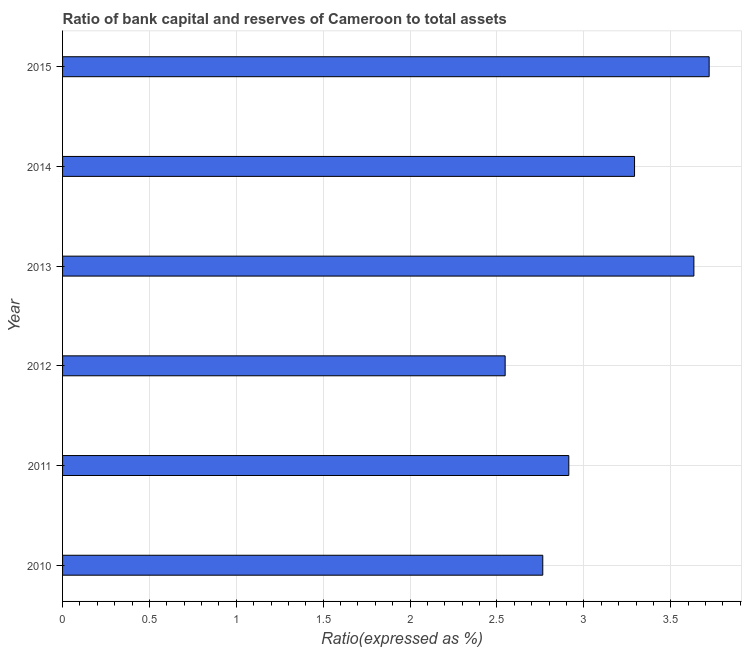Does the graph contain grids?
Give a very brief answer. Yes. What is the title of the graph?
Give a very brief answer. Ratio of bank capital and reserves of Cameroon to total assets. What is the label or title of the X-axis?
Your response must be concise. Ratio(expressed as %). What is the bank capital to assets ratio in 2014?
Offer a very short reply. 3.29. Across all years, what is the maximum bank capital to assets ratio?
Offer a very short reply. 3.72. Across all years, what is the minimum bank capital to assets ratio?
Make the answer very short. 2.55. In which year was the bank capital to assets ratio maximum?
Your response must be concise. 2015. In which year was the bank capital to assets ratio minimum?
Your answer should be very brief. 2012. What is the sum of the bank capital to assets ratio?
Keep it short and to the point. 18.87. What is the difference between the bank capital to assets ratio in 2011 and 2012?
Your answer should be very brief. 0.37. What is the average bank capital to assets ratio per year?
Provide a short and direct response. 3.15. What is the median bank capital to assets ratio?
Give a very brief answer. 3.1. In how many years, is the bank capital to assets ratio greater than 1 %?
Provide a short and direct response. 6. Do a majority of the years between 2015 and 2011 (inclusive) have bank capital to assets ratio greater than 0.5 %?
Ensure brevity in your answer.  Yes. What is the ratio of the bank capital to assets ratio in 2010 to that in 2012?
Offer a terse response. 1.08. What is the difference between the highest and the second highest bank capital to assets ratio?
Keep it short and to the point. 0.09. What is the difference between the highest and the lowest bank capital to assets ratio?
Offer a very short reply. 1.17. How many years are there in the graph?
Make the answer very short. 6. Are the values on the major ticks of X-axis written in scientific E-notation?
Provide a succinct answer. No. What is the Ratio(expressed as %) in 2010?
Offer a very short reply. 2.76. What is the Ratio(expressed as %) of 2011?
Provide a short and direct response. 2.91. What is the Ratio(expressed as %) in 2012?
Make the answer very short. 2.55. What is the Ratio(expressed as %) of 2013?
Make the answer very short. 3.63. What is the Ratio(expressed as %) in 2014?
Keep it short and to the point. 3.29. What is the Ratio(expressed as %) in 2015?
Offer a terse response. 3.72. What is the difference between the Ratio(expressed as %) in 2010 and 2011?
Give a very brief answer. -0.15. What is the difference between the Ratio(expressed as %) in 2010 and 2012?
Offer a very short reply. 0.22. What is the difference between the Ratio(expressed as %) in 2010 and 2013?
Give a very brief answer. -0.87. What is the difference between the Ratio(expressed as %) in 2010 and 2014?
Keep it short and to the point. -0.53. What is the difference between the Ratio(expressed as %) in 2010 and 2015?
Offer a terse response. -0.96. What is the difference between the Ratio(expressed as %) in 2011 and 2012?
Offer a very short reply. 0.37. What is the difference between the Ratio(expressed as %) in 2011 and 2013?
Ensure brevity in your answer.  -0.72. What is the difference between the Ratio(expressed as %) in 2011 and 2014?
Give a very brief answer. -0.38. What is the difference between the Ratio(expressed as %) in 2011 and 2015?
Give a very brief answer. -0.81. What is the difference between the Ratio(expressed as %) in 2012 and 2013?
Your response must be concise. -1.09. What is the difference between the Ratio(expressed as %) in 2012 and 2014?
Ensure brevity in your answer.  -0.74. What is the difference between the Ratio(expressed as %) in 2012 and 2015?
Provide a succinct answer. -1.17. What is the difference between the Ratio(expressed as %) in 2013 and 2014?
Offer a terse response. 0.34. What is the difference between the Ratio(expressed as %) in 2013 and 2015?
Keep it short and to the point. -0.09. What is the difference between the Ratio(expressed as %) in 2014 and 2015?
Give a very brief answer. -0.43. What is the ratio of the Ratio(expressed as %) in 2010 to that in 2011?
Your answer should be very brief. 0.95. What is the ratio of the Ratio(expressed as %) in 2010 to that in 2012?
Your answer should be compact. 1.08. What is the ratio of the Ratio(expressed as %) in 2010 to that in 2013?
Your response must be concise. 0.76. What is the ratio of the Ratio(expressed as %) in 2010 to that in 2014?
Your answer should be compact. 0.84. What is the ratio of the Ratio(expressed as %) in 2010 to that in 2015?
Give a very brief answer. 0.74. What is the ratio of the Ratio(expressed as %) in 2011 to that in 2012?
Provide a short and direct response. 1.14. What is the ratio of the Ratio(expressed as %) in 2011 to that in 2013?
Your answer should be very brief. 0.8. What is the ratio of the Ratio(expressed as %) in 2011 to that in 2014?
Make the answer very short. 0.89. What is the ratio of the Ratio(expressed as %) in 2011 to that in 2015?
Your answer should be compact. 0.78. What is the ratio of the Ratio(expressed as %) in 2012 to that in 2013?
Make the answer very short. 0.7. What is the ratio of the Ratio(expressed as %) in 2012 to that in 2014?
Provide a succinct answer. 0.77. What is the ratio of the Ratio(expressed as %) in 2012 to that in 2015?
Offer a very short reply. 0.69. What is the ratio of the Ratio(expressed as %) in 2013 to that in 2014?
Offer a very short reply. 1.1. What is the ratio of the Ratio(expressed as %) in 2013 to that in 2015?
Provide a succinct answer. 0.98. What is the ratio of the Ratio(expressed as %) in 2014 to that in 2015?
Give a very brief answer. 0.89. 